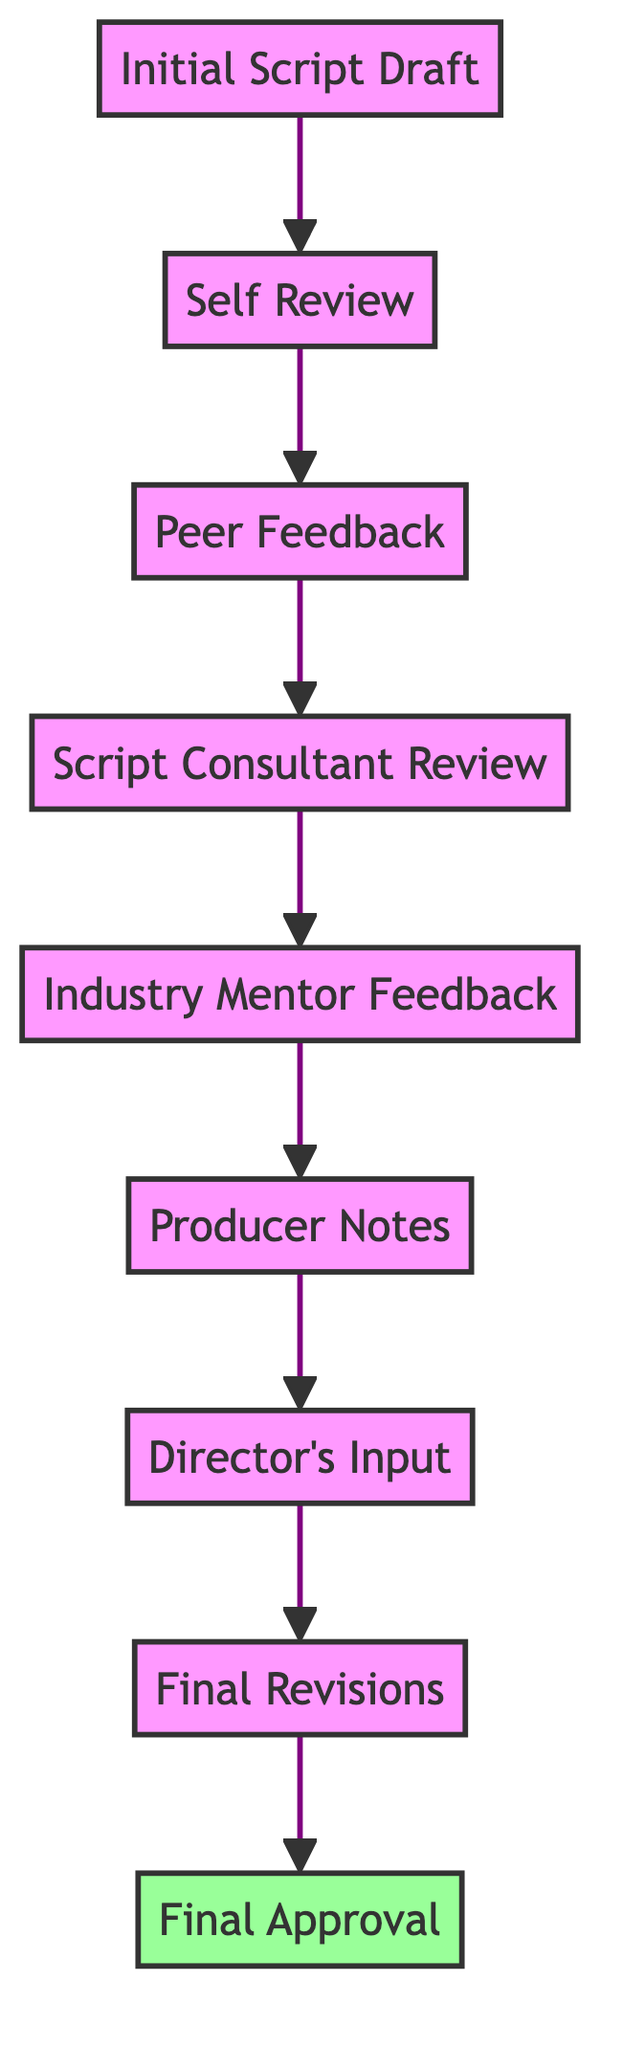What is the first step after the initial script draft? The diagram indicates that the first step following the "Initial Script Draft" node is "Self Review."
Answer: Self Review How many total nodes are present in the diagram? The diagram lists a total of nine nodes representing various stages in the script feedback loop.
Answer: 9 Who provides feedback immediately after the peer feedback? According to the diagram, feedback is provided by the "Script Consultant" immediately following "Peer Feedback."
Answer: Script Consultant Review What is the last step before final approval? The diagram shows that the last step prior to "Final Approval" is "Final Revisions."
Answer: Final Revisions How many edges lead to the "Final Approval" node? There is only one edge that leads directly to the "Final Approval" node, stemming from "Final Revisions."
Answer: 1 What is the relationship between "Producer Notes" and "Director's Input"? The diagram illustrates that "Producer Notes" directly leads to "Director's Input," indicating a sequential relationship between these two nodes.
Answer: Producer Notes → Director's Input What are the last two stages in the feedback loop before the final approval? The final two stages in the diagram, before reaching the "Final Approval," are "Final Revisions" followed by "Final Approval."
Answer: Final Revisions, Final Approval 